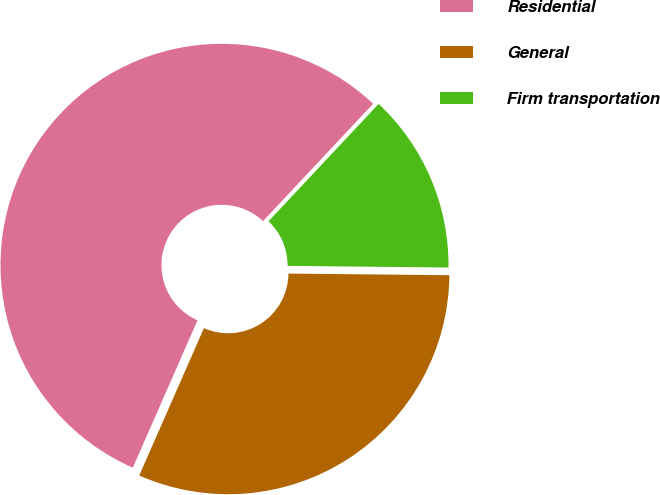Convert chart to OTSL. <chart><loc_0><loc_0><loc_500><loc_500><pie_chart><fcel>Residential<fcel>General<fcel>Firm transportation<nl><fcel>55.41%<fcel>31.42%<fcel>13.17%<nl></chart> 